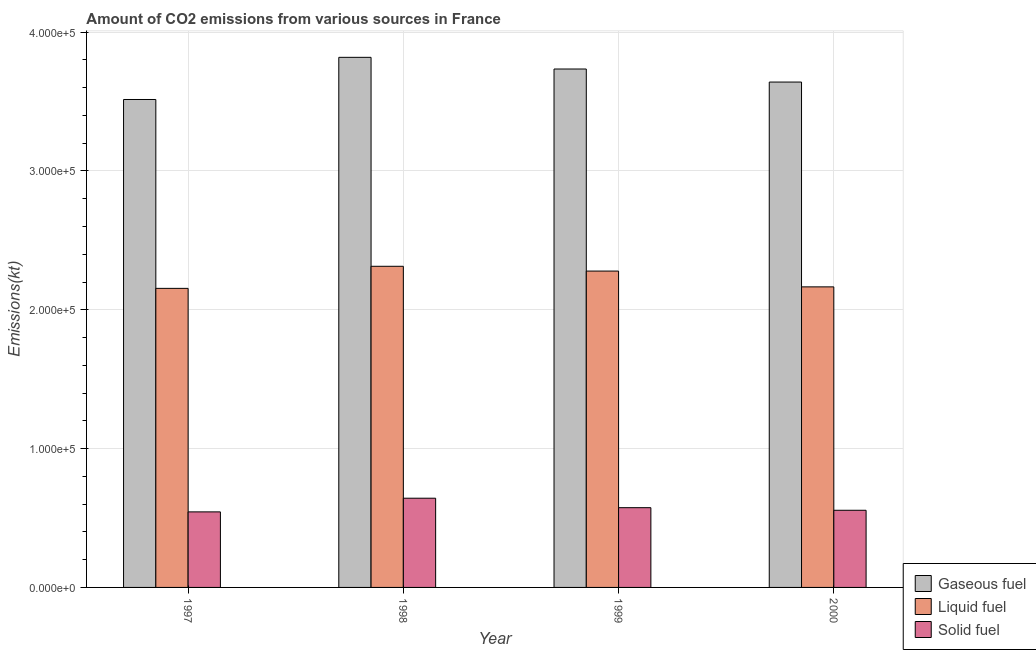How many groups of bars are there?
Provide a succinct answer. 4. Are the number of bars on each tick of the X-axis equal?
Ensure brevity in your answer.  Yes. How many bars are there on the 3rd tick from the right?
Your answer should be compact. 3. What is the label of the 3rd group of bars from the left?
Provide a succinct answer. 1999. What is the amount of co2 emissions from solid fuel in 1997?
Your answer should be very brief. 5.44e+04. Across all years, what is the maximum amount of co2 emissions from liquid fuel?
Your answer should be very brief. 2.31e+05. Across all years, what is the minimum amount of co2 emissions from solid fuel?
Provide a short and direct response. 5.44e+04. In which year was the amount of co2 emissions from liquid fuel maximum?
Offer a terse response. 1998. In which year was the amount of co2 emissions from liquid fuel minimum?
Ensure brevity in your answer.  1997. What is the total amount of co2 emissions from gaseous fuel in the graph?
Give a very brief answer. 1.47e+06. What is the difference between the amount of co2 emissions from liquid fuel in 1997 and that in 2000?
Ensure brevity in your answer.  -1074.43. What is the difference between the amount of co2 emissions from liquid fuel in 2000 and the amount of co2 emissions from gaseous fuel in 1998?
Your response must be concise. -1.48e+04. What is the average amount of co2 emissions from gaseous fuel per year?
Your answer should be compact. 3.68e+05. What is the ratio of the amount of co2 emissions from gaseous fuel in 1997 to that in 1999?
Provide a short and direct response. 0.94. Is the difference between the amount of co2 emissions from solid fuel in 1999 and 2000 greater than the difference between the amount of co2 emissions from gaseous fuel in 1999 and 2000?
Provide a short and direct response. No. What is the difference between the highest and the second highest amount of co2 emissions from solid fuel?
Give a very brief answer. 6824.29. What is the difference between the highest and the lowest amount of co2 emissions from liquid fuel?
Offer a terse response. 1.59e+04. Is the sum of the amount of co2 emissions from solid fuel in 1997 and 2000 greater than the maximum amount of co2 emissions from liquid fuel across all years?
Offer a terse response. Yes. What does the 3rd bar from the left in 2000 represents?
Your answer should be very brief. Solid fuel. What does the 1st bar from the right in 1997 represents?
Keep it short and to the point. Solid fuel. How many bars are there?
Your response must be concise. 12. Are the values on the major ticks of Y-axis written in scientific E-notation?
Offer a terse response. Yes. Does the graph contain grids?
Make the answer very short. Yes. Where does the legend appear in the graph?
Your answer should be very brief. Bottom right. What is the title of the graph?
Keep it short and to the point. Amount of CO2 emissions from various sources in France. Does "Agricultural Nitrous Oxide" appear as one of the legend labels in the graph?
Offer a terse response. No. What is the label or title of the Y-axis?
Your answer should be compact. Emissions(kt). What is the Emissions(kt) in Gaseous fuel in 1997?
Give a very brief answer. 3.52e+05. What is the Emissions(kt) in Liquid fuel in 1997?
Provide a short and direct response. 2.15e+05. What is the Emissions(kt) of Solid fuel in 1997?
Your response must be concise. 5.44e+04. What is the Emissions(kt) in Gaseous fuel in 1998?
Your answer should be very brief. 3.82e+05. What is the Emissions(kt) in Liquid fuel in 1998?
Provide a succinct answer. 2.31e+05. What is the Emissions(kt) in Solid fuel in 1998?
Your response must be concise. 6.43e+04. What is the Emissions(kt) in Gaseous fuel in 1999?
Your response must be concise. 3.73e+05. What is the Emissions(kt) of Liquid fuel in 1999?
Your response must be concise. 2.28e+05. What is the Emissions(kt) of Solid fuel in 1999?
Provide a short and direct response. 5.75e+04. What is the Emissions(kt) in Gaseous fuel in 2000?
Give a very brief answer. 3.64e+05. What is the Emissions(kt) in Liquid fuel in 2000?
Your response must be concise. 2.17e+05. What is the Emissions(kt) in Solid fuel in 2000?
Give a very brief answer. 5.56e+04. Across all years, what is the maximum Emissions(kt) of Gaseous fuel?
Make the answer very short. 3.82e+05. Across all years, what is the maximum Emissions(kt) in Liquid fuel?
Your answer should be very brief. 2.31e+05. Across all years, what is the maximum Emissions(kt) of Solid fuel?
Ensure brevity in your answer.  6.43e+04. Across all years, what is the minimum Emissions(kt) in Gaseous fuel?
Give a very brief answer. 3.52e+05. Across all years, what is the minimum Emissions(kt) of Liquid fuel?
Keep it short and to the point. 2.15e+05. Across all years, what is the minimum Emissions(kt) of Solid fuel?
Keep it short and to the point. 5.44e+04. What is the total Emissions(kt) in Gaseous fuel in the graph?
Your answer should be compact. 1.47e+06. What is the total Emissions(kt) in Liquid fuel in the graph?
Keep it short and to the point. 8.91e+05. What is the total Emissions(kt) of Solid fuel in the graph?
Offer a terse response. 2.32e+05. What is the difference between the Emissions(kt) of Gaseous fuel in 1997 and that in 1998?
Provide a succinct answer. -3.04e+04. What is the difference between the Emissions(kt) in Liquid fuel in 1997 and that in 1998?
Give a very brief answer. -1.59e+04. What is the difference between the Emissions(kt) of Solid fuel in 1997 and that in 1998?
Provide a succinct answer. -9849.56. What is the difference between the Emissions(kt) in Gaseous fuel in 1997 and that in 1999?
Keep it short and to the point. -2.20e+04. What is the difference between the Emissions(kt) in Liquid fuel in 1997 and that in 1999?
Offer a terse response. -1.25e+04. What is the difference between the Emissions(kt) in Solid fuel in 1997 and that in 1999?
Provide a succinct answer. -3025.28. What is the difference between the Emissions(kt) of Gaseous fuel in 1997 and that in 2000?
Your response must be concise. -1.26e+04. What is the difference between the Emissions(kt) in Liquid fuel in 1997 and that in 2000?
Your answer should be very brief. -1074.43. What is the difference between the Emissions(kt) in Solid fuel in 1997 and that in 2000?
Offer a very short reply. -1158.77. What is the difference between the Emissions(kt) of Gaseous fuel in 1998 and that in 1999?
Ensure brevity in your answer.  8415.76. What is the difference between the Emissions(kt) of Liquid fuel in 1998 and that in 1999?
Offer a terse response. 3446.98. What is the difference between the Emissions(kt) in Solid fuel in 1998 and that in 1999?
Ensure brevity in your answer.  6824.29. What is the difference between the Emissions(kt) of Gaseous fuel in 1998 and that in 2000?
Make the answer very short. 1.78e+04. What is the difference between the Emissions(kt) in Liquid fuel in 1998 and that in 2000?
Your answer should be compact. 1.48e+04. What is the difference between the Emissions(kt) of Solid fuel in 1998 and that in 2000?
Keep it short and to the point. 8690.79. What is the difference between the Emissions(kt) in Gaseous fuel in 1999 and that in 2000?
Your response must be concise. 9398.52. What is the difference between the Emissions(kt) in Liquid fuel in 1999 and that in 2000?
Give a very brief answer. 1.14e+04. What is the difference between the Emissions(kt) of Solid fuel in 1999 and that in 2000?
Offer a terse response. 1866.5. What is the difference between the Emissions(kt) in Gaseous fuel in 1997 and the Emissions(kt) in Liquid fuel in 1998?
Your answer should be compact. 1.20e+05. What is the difference between the Emissions(kt) of Gaseous fuel in 1997 and the Emissions(kt) of Solid fuel in 1998?
Your response must be concise. 2.87e+05. What is the difference between the Emissions(kt) in Liquid fuel in 1997 and the Emissions(kt) in Solid fuel in 1998?
Provide a short and direct response. 1.51e+05. What is the difference between the Emissions(kt) in Gaseous fuel in 1997 and the Emissions(kt) in Liquid fuel in 1999?
Your answer should be compact. 1.24e+05. What is the difference between the Emissions(kt) in Gaseous fuel in 1997 and the Emissions(kt) in Solid fuel in 1999?
Offer a terse response. 2.94e+05. What is the difference between the Emissions(kt) in Liquid fuel in 1997 and the Emissions(kt) in Solid fuel in 1999?
Make the answer very short. 1.58e+05. What is the difference between the Emissions(kt) in Gaseous fuel in 1997 and the Emissions(kt) in Liquid fuel in 2000?
Provide a succinct answer. 1.35e+05. What is the difference between the Emissions(kt) of Gaseous fuel in 1997 and the Emissions(kt) of Solid fuel in 2000?
Your answer should be very brief. 2.96e+05. What is the difference between the Emissions(kt) of Liquid fuel in 1997 and the Emissions(kt) of Solid fuel in 2000?
Ensure brevity in your answer.  1.60e+05. What is the difference between the Emissions(kt) of Gaseous fuel in 1998 and the Emissions(kt) of Liquid fuel in 1999?
Provide a short and direct response. 1.54e+05. What is the difference between the Emissions(kt) of Gaseous fuel in 1998 and the Emissions(kt) of Solid fuel in 1999?
Your answer should be compact. 3.24e+05. What is the difference between the Emissions(kt) of Liquid fuel in 1998 and the Emissions(kt) of Solid fuel in 1999?
Your response must be concise. 1.74e+05. What is the difference between the Emissions(kt) of Gaseous fuel in 1998 and the Emissions(kt) of Liquid fuel in 2000?
Give a very brief answer. 1.65e+05. What is the difference between the Emissions(kt) of Gaseous fuel in 1998 and the Emissions(kt) of Solid fuel in 2000?
Offer a terse response. 3.26e+05. What is the difference between the Emissions(kt) in Liquid fuel in 1998 and the Emissions(kt) in Solid fuel in 2000?
Your response must be concise. 1.76e+05. What is the difference between the Emissions(kt) in Gaseous fuel in 1999 and the Emissions(kt) in Liquid fuel in 2000?
Make the answer very short. 1.57e+05. What is the difference between the Emissions(kt) in Gaseous fuel in 1999 and the Emissions(kt) in Solid fuel in 2000?
Provide a succinct answer. 3.18e+05. What is the difference between the Emissions(kt) in Liquid fuel in 1999 and the Emissions(kt) in Solid fuel in 2000?
Offer a terse response. 1.72e+05. What is the average Emissions(kt) in Gaseous fuel per year?
Offer a terse response. 3.68e+05. What is the average Emissions(kt) in Liquid fuel per year?
Your answer should be compact. 2.23e+05. What is the average Emissions(kt) of Solid fuel per year?
Keep it short and to the point. 5.79e+04. In the year 1997, what is the difference between the Emissions(kt) of Gaseous fuel and Emissions(kt) of Liquid fuel?
Offer a terse response. 1.36e+05. In the year 1997, what is the difference between the Emissions(kt) of Gaseous fuel and Emissions(kt) of Solid fuel?
Keep it short and to the point. 2.97e+05. In the year 1997, what is the difference between the Emissions(kt) of Liquid fuel and Emissions(kt) of Solid fuel?
Offer a very short reply. 1.61e+05. In the year 1998, what is the difference between the Emissions(kt) in Gaseous fuel and Emissions(kt) in Liquid fuel?
Your answer should be compact. 1.51e+05. In the year 1998, what is the difference between the Emissions(kt) of Gaseous fuel and Emissions(kt) of Solid fuel?
Make the answer very short. 3.18e+05. In the year 1998, what is the difference between the Emissions(kt) in Liquid fuel and Emissions(kt) in Solid fuel?
Give a very brief answer. 1.67e+05. In the year 1999, what is the difference between the Emissions(kt) in Gaseous fuel and Emissions(kt) in Liquid fuel?
Provide a short and direct response. 1.46e+05. In the year 1999, what is the difference between the Emissions(kt) of Gaseous fuel and Emissions(kt) of Solid fuel?
Ensure brevity in your answer.  3.16e+05. In the year 1999, what is the difference between the Emissions(kt) of Liquid fuel and Emissions(kt) of Solid fuel?
Ensure brevity in your answer.  1.70e+05. In the year 2000, what is the difference between the Emissions(kt) in Gaseous fuel and Emissions(kt) in Liquid fuel?
Offer a terse response. 1.48e+05. In the year 2000, what is the difference between the Emissions(kt) in Gaseous fuel and Emissions(kt) in Solid fuel?
Provide a succinct answer. 3.08e+05. In the year 2000, what is the difference between the Emissions(kt) of Liquid fuel and Emissions(kt) of Solid fuel?
Provide a succinct answer. 1.61e+05. What is the ratio of the Emissions(kt) in Gaseous fuel in 1997 to that in 1998?
Give a very brief answer. 0.92. What is the ratio of the Emissions(kt) of Liquid fuel in 1997 to that in 1998?
Provide a short and direct response. 0.93. What is the ratio of the Emissions(kt) of Solid fuel in 1997 to that in 1998?
Provide a succinct answer. 0.85. What is the ratio of the Emissions(kt) of Liquid fuel in 1997 to that in 1999?
Your response must be concise. 0.95. What is the ratio of the Emissions(kt) in Solid fuel in 1997 to that in 1999?
Your answer should be very brief. 0.95. What is the ratio of the Emissions(kt) in Gaseous fuel in 1997 to that in 2000?
Your response must be concise. 0.97. What is the ratio of the Emissions(kt) in Solid fuel in 1997 to that in 2000?
Keep it short and to the point. 0.98. What is the ratio of the Emissions(kt) in Gaseous fuel in 1998 to that in 1999?
Keep it short and to the point. 1.02. What is the ratio of the Emissions(kt) in Liquid fuel in 1998 to that in 1999?
Your answer should be very brief. 1.02. What is the ratio of the Emissions(kt) in Solid fuel in 1998 to that in 1999?
Provide a short and direct response. 1.12. What is the ratio of the Emissions(kt) of Gaseous fuel in 1998 to that in 2000?
Make the answer very short. 1.05. What is the ratio of the Emissions(kt) in Liquid fuel in 1998 to that in 2000?
Your response must be concise. 1.07. What is the ratio of the Emissions(kt) in Solid fuel in 1998 to that in 2000?
Make the answer very short. 1.16. What is the ratio of the Emissions(kt) in Gaseous fuel in 1999 to that in 2000?
Offer a very short reply. 1.03. What is the ratio of the Emissions(kt) in Liquid fuel in 1999 to that in 2000?
Provide a succinct answer. 1.05. What is the ratio of the Emissions(kt) of Solid fuel in 1999 to that in 2000?
Keep it short and to the point. 1.03. What is the difference between the highest and the second highest Emissions(kt) in Gaseous fuel?
Provide a short and direct response. 8415.76. What is the difference between the highest and the second highest Emissions(kt) in Liquid fuel?
Your answer should be compact. 3446.98. What is the difference between the highest and the second highest Emissions(kt) of Solid fuel?
Provide a short and direct response. 6824.29. What is the difference between the highest and the lowest Emissions(kt) of Gaseous fuel?
Make the answer very short. 3.04e+04. What is the difference between the highest and the lowest Emissions(kt) in Liquid fuel?
Your answer should be compact. 1.59e+04. What is the difference between the highest and the lowest Emissions(kt) in Solid fuel?
Offer a terse response. 9849.56. 